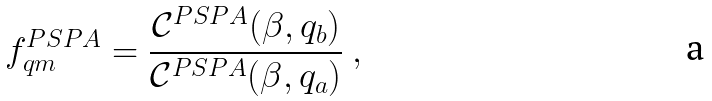<formula> <loc_0><loc_0><loc_500><loc_500>f _ { q m } ^ { P S P A } = \frac { { \mathcal { C } } ^ { P S P A } ( \beta , q _ { b } ) } { { \mathcal { C } } ^ { P S P A } ( \beta , q _ { a } ) } \ ,</formula> 